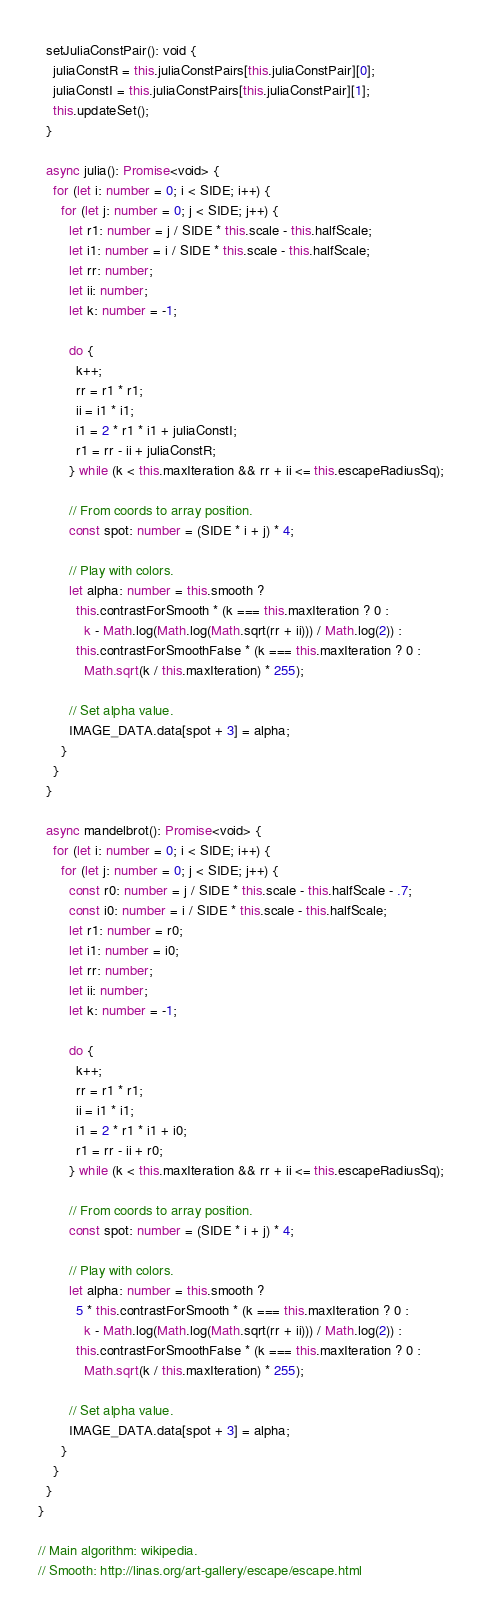Convert code to text. <code><loc_0><loc_0><loc_500><loc_500><_TypeScript_>  setJuliaConstPair(): void {
    juliaConstR = this.juliaConstPairs[this.juliaConstPair][0];
    juliaConstI = this.juliaConstPairs[this.juliaConstPair][1];
    this.updateSet();
  }

  async julia(): Promise<void> {
    for (let i: number = 0; i < SIDE; i++) {
      for (let j: number = 0; j < SIDE; j++) {
        let r1: number = j / SIDE * this.scale - this.halfScale;
        let i1: number = i / SIDE * this.scale - this.halfScale;
        let rr: number;
        let ii: number;
        let k: number = -1;

        do {
          k++;
          rr = r1 * r1;
          ii = i1 * i1;
          i1 = 2 * r1 * i1 + juliaConstI;
          r1 = rr - ii + juliaConstR;
        } while (k < this.maxIteration && rr + ii <= this.escapeRadiusSq);

        // From coords to array position.
        const spot: number = (SIDE * i + j) * 4;

        // Play with colors.
        let alpha: number = this.smooth ?
          this.contrastForSmooth * (k === this.maxIteration ? 0 :
            k - Math.log(Math.log(Math.sqrt(rr + ii))) / Math.log(2)) :
          this.contrastForSmoothFalse * (k === this.maxIteration ? 0 :
            Math.sqrt(k / this.maxIteration) * 255);

        // Set alpha value.
        IMAGE_DATA.data[spot + 3] = alpha;
      }
    }
  }

  async mandelbrot(): Promise<void> {
    for (let i: number = 0; i < SIDE; i++) {
      for (let j: number = 0; j < SIDE; j++) {
        const r0: number = j / SIDE * this.scale - this.halfScale - .7;
        const i0: number = i / SIDE * this.scale - this.halfScale;
        let r1: number = r0;
        let i1: number = i0;
        let rr: number;
        let ii: number;
        let k: number = -1;

        do {
          k++;
          rr = r1 * r1;
          ii = i1 * i1;
          i1 = 2 * r1 * i1 + i0;
          r1 = rr - ii + r0;
        } while (k < this.maxIteration && rr + ii <= this.escapeRadiusSq);

        // From coords to array position.
        const spot: number = (SIDE * i + j) * 4;

        // Play with colors.
        let alpha: number = this.smooth ?
          5 * this.contrastForSmooth * (k === this.maxIteration ? 0 :
            k - Math.log(Math.log(Math.sqrt(rr + ii))) / Math.log(2)) :
          this.contrastForSmoothFalse * (k === this.maxIteration ? 0 :
            Math.sqrt(k / this.maxIteration) * 255);

        // Set alpha value.
        IMAGE_DATA.data[spot + 3] = alpha;
      }
    }
  }
}

// Main algorithm: wikipedia.
// Smooth: http://linas.org/art-gallery/escape/escape.html
</code> 